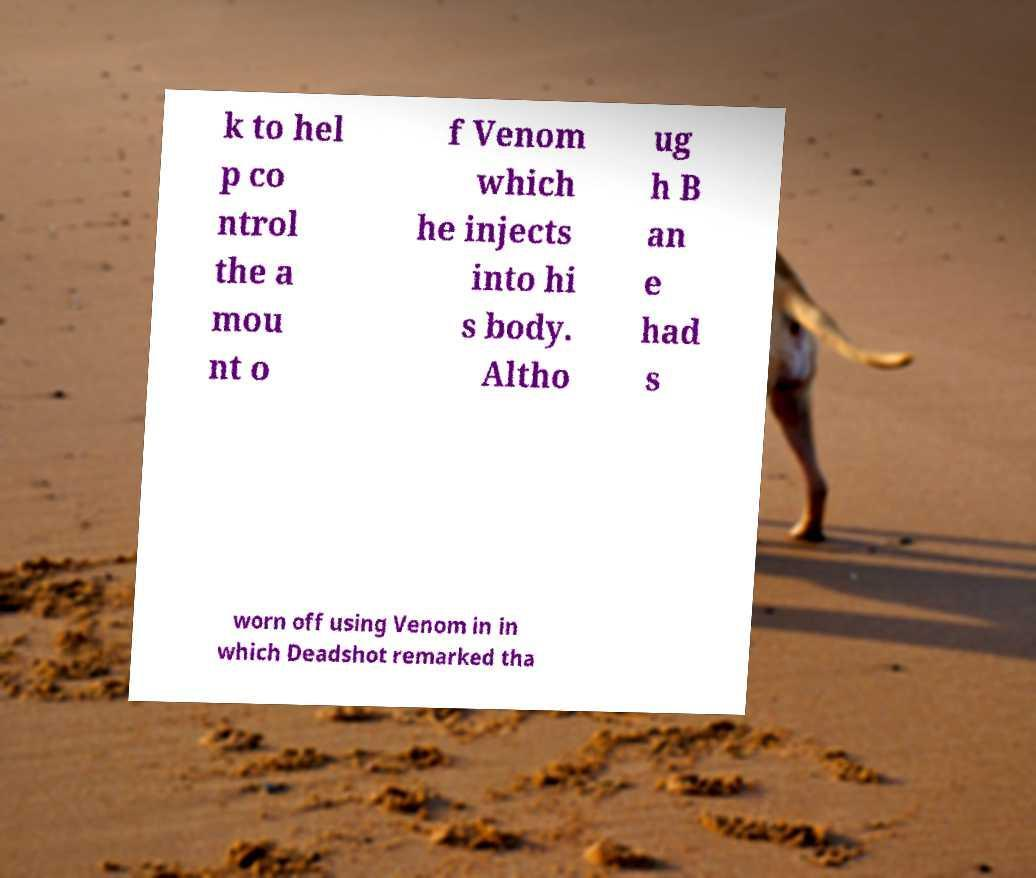Can you accurately transcribe the text from the provided image for me? k to hel p co ntrol the a mou nt o f Venom which he injects into hi s body. Altho ug h B an e had s worn off using Venom in in which Deadshot remarked tha 